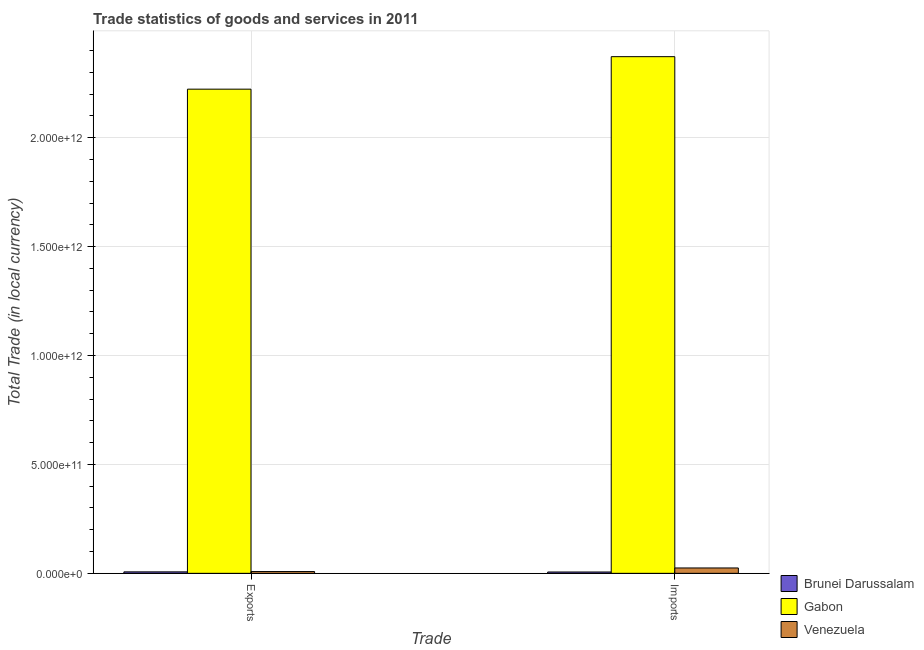How many groups of bars are there?
Ensure brevity in your answer.  2. Are the number of bars on each tick of the X-axis equal?
Keep it short and to the point. Yes. What is the label of the 1st group of bars from the left?
Ensure brevity in your answer.  Exports. What is the imports of goods and services in Gabon?
Your answer should be very brief. 2.37e+12. Across all countries, what is the maximum imports of goods and services?
Your answer should be compact. 2.37e+12. Across all countries, what is the minimum export of goods and services?
Make the answer very short. 6.70e+09. In which country was the imports of goods and services maximum?
Your response must be concise. Gabon. In which country was the imports of goods and services minimum?
Provide a short and direct response. Brunei Darussalam. What is the total imports of goods and services in the graph?
Offer a terse response. 2.40e+12. What is the difference between the imports of goods and services in Venezuela and that in Gabon?
Offer a very short reply. -2.35e+12. What is the difference between the imports of goods and services in Gabon and the export of goods and services in Venezuela?
Offer a very short reply. 2.36e+12. What is the average imports of goods and services per country?
Ensure brevity in your answer.  8.01e+11. What is the difference between the imports of goods and services and export of goods and services in Gabon?
Ensure brevity in your answer.  1.49e+11. In how many countries, is the export of goods and services greater than 500000000000 LCU?
Offer a terse response. 1. What is the ratio of the imports of goods and services in Brunei Darussalam to that in Gabon?
Make the answer very short. 0. In how many countries, is the imports of goods and services greater than the average imports of goods and services taken over all countries?
Make the answer very short. 1. What does the 1st bar from the left in Imports represents?
Give a very brief answer. Brunei Darussalam. What does the 3rd bar from the right in Exports represents?
Ensure brevity in your answer.  Brunei Darussalam. How many bars are there?
Provide a short and direct response. 6. Are all the bars in the graph horizontal?
Offer a terse response. No. How many countries are there in the graph?
Provide a succinct answer. 3. What is the difference between two consecutive major ticks on the Y-axis?
Make the answer very short. 5.00e+11. Where does the legend appear in the graph?
Your response must be concise. Bottom right. How many legend labels are there?
Make the answer very short. 3. What is the title of the graph?
Your response must be concise. Trade statistics of goods and services in 2011. What is the label or title of the X-axis?
Your answer should be compact. Trade. What is the label or title of the Y-axis?
Provide a succinct answer. Total Trade (in local currency). What is the Total Trade (in local currency) of Brunei Darussalam in Exports?
Keep it short and to the point. 6.70e+09. What is the Total Trade (in local currency) of Gabon in Exports?
Ensure brevity in your answer.  2.22e+12. What is the Total Trade (in local currency) of Venezuela in Exports?
Keep it short and to the point. 8.19e+09. What is the Total Trade (in local currency) of Brunei Darussalam in Imports?
Your answer should be very brief. 6.13e+09. What is the Total Trade (in local currency) of Gabon in Imports?
Offer a very short reply. 2.37e+12. What is the Total Trade (in local currency) in Venezuela in Imports?
Your response must be concise. 2.46e+1. Across all Trade, what is the maximum Total Trade (in local currency) in Brunei Darussalam?
Your answer should be very brief. 6.70e+09. Across all Trade, what is the maximum Total Trade (in local currency) in Gabon?
Your answer should be very brief. 2.37e+12. Across all Trade, what is the maximum Total Trade (in local currency) in Venezuela?
Your answer should be very brief. 2.46e+1. Across all Trade, what is the minimum Total Trade (in local currency) of Brunei Darussalam?
Your response must be concise. 6.13e+09. Across all Trade, what is the minimum Total Trade (in local currency) of Gabon?
Your answer should be compact. 2.22e+12. Across all Trade, what is the minimum Total Trade (in local currency) of Venezuela?
Ensure brevity in your answer.  8.19e+09. What is the total Total Trade (in local currency) of Brunei Darussalam in the graph?
Your answer should be compact. 1.28e+1. What is the total Total Trade (in local currency) in Gabon in the graph?
Offer a very short reply. 4.59e+12. What is the total Total Trade (in local currency) in Venezuela in the graph?
Offer a very short reply. 3.28e+1. What is the difference between the Total Trade (in local currency) of Brunei Darussalam in Exports and that in Imports?
Provide a short and direct response. 5.71e+08. What is the difference between the Total Trade (in local currency) of Gabon in Exports and that in Imports?
Make the answer very short. -1.49e+11. What is the difference between the Total Trade (in local currency) in Venezuela in Exports and that in Imports?
Offer a very short reply. -1.64e+1. What is the difference between the Total Trade (in local currency) of Brunei Darussalam in Exports and the Total Trade (in local currency) of Gabon in Imports?
Offer a very short reply. -2.37e+12. What is the difference between the Total Trade (in local currency) of Brunei Darussalam in Exports and the Total Trade (in local currency) of Venezuela in Imports?
Offer a terse response. -1.79e+1. What is the difference between the Total Trade (in local currency) in Gabon in Exports and the Total Trade (in local currency) in Venezuela in Imports?
Ensure brevity in your answer.  2.20e+12. What is the average Total Trade (in local currency) of Brunei Darussalam per Trade?
Provide a short and direct response. 6.42e+09. What is the average Total Trade (in local currency) in Gabon per Trade?
Make the answer very short. 2.30e+12. What is the average Total Trade (in local currency) in Venezuela per Trade?
Offer a terse response. 1.64e+1. What is the difference between the Total Trade (in local currency) in Brunei Darussalam and Total Trade (in local currency) in Gabon in Exports?
Your answer should be compact. -2.22e+12. What is the difference between the Total Trade (in local currency) in Brunei Darussalam and Total Trade (in local currency) in Venezuela in Exports?
Provide a succinct answer. -1.49e+09. What is the difference between the Total Trade (in local currency) in Gabon and Total Trade (in local currency) in Venezuela in Exports?
Ensure brevity in your answer.  2.21e+12. What is the difference between the Total Trade (in local currency) in Brunei Darussalam and Total Trade (in local currency) in Gabon in Imports?
Make the answer very short. -2.37e+12. What is the difference between the Total Trade (in local currency) in Brunei Darussalam and Total Trade (in local currency) in Venezuela in Imports?
Your answer should be compact. -1.85e+1. What is the difference between the Total Trade (in local currency) of Gabon and Total Trade (in local currency) of Venezuela in Imports?
Provide a short and direct response. 2.35e+12. What is the ratio of the Total Trade (in local currency) of Brunei Darussalam in Exports to that in Imports?
Provide a succinct answer. 1.09. What is the ratio of the Total Trade (in local currency) in Gabon in Exports to that in Imports?
Your response must be concise. 0.94. What is the ratio of the Total Trade (in local currency) in Venezuela in Exports to that in Imports?
Keep it short and to the point. 0.33. What is the difference between the highest and the second highest Total Trade (in local currency) in Brunei Darussalam?
Your response must be concise. 5.71e+08. What is the difference between the highest and the second highest Total Trade (in local currency) in Gabon?
Offer a terse response. 1.49e+11. What is the difference between the highest and the second highest Total Trade (in local currency) of Venezuela?
Your answer should be compact. 1.64e+1. What is the difference between the highest and the lowest Total Trade (in local currency) in Brunei Darussalam?
Ensure brevity in your answer.  5.71e+08. What is the difference between the highest and the lowest Total Trade (in local currency) of Gabon?
Your response must be concise. 1.49e+11. What is the difference between the highest and the lowest Total Trade (in local currency) in Venezuela?
Offer a terse response. 1.64e+1. 